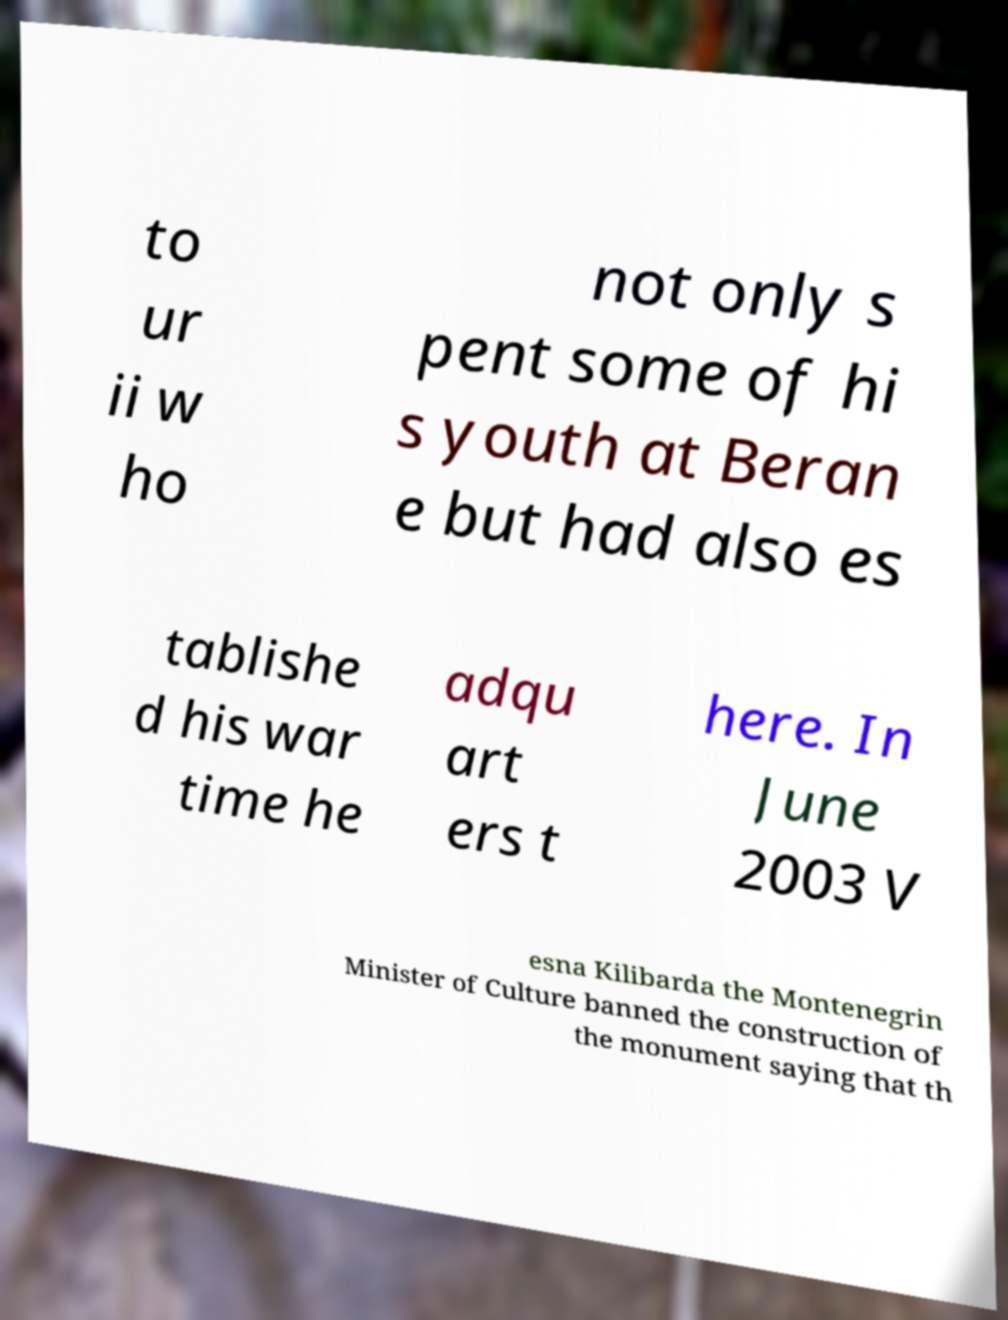There's text embedded in this image that I need extracted. Can you transcribe it verbatim? to ur ii w ho not only s pent some of hi s youth at Beran e but had also es tablishe d his war time he adqu art ers t here. In June 2003 V esna Kilibarda the Montenegrin Minister of Culture banned the construction of the monument saying that th 